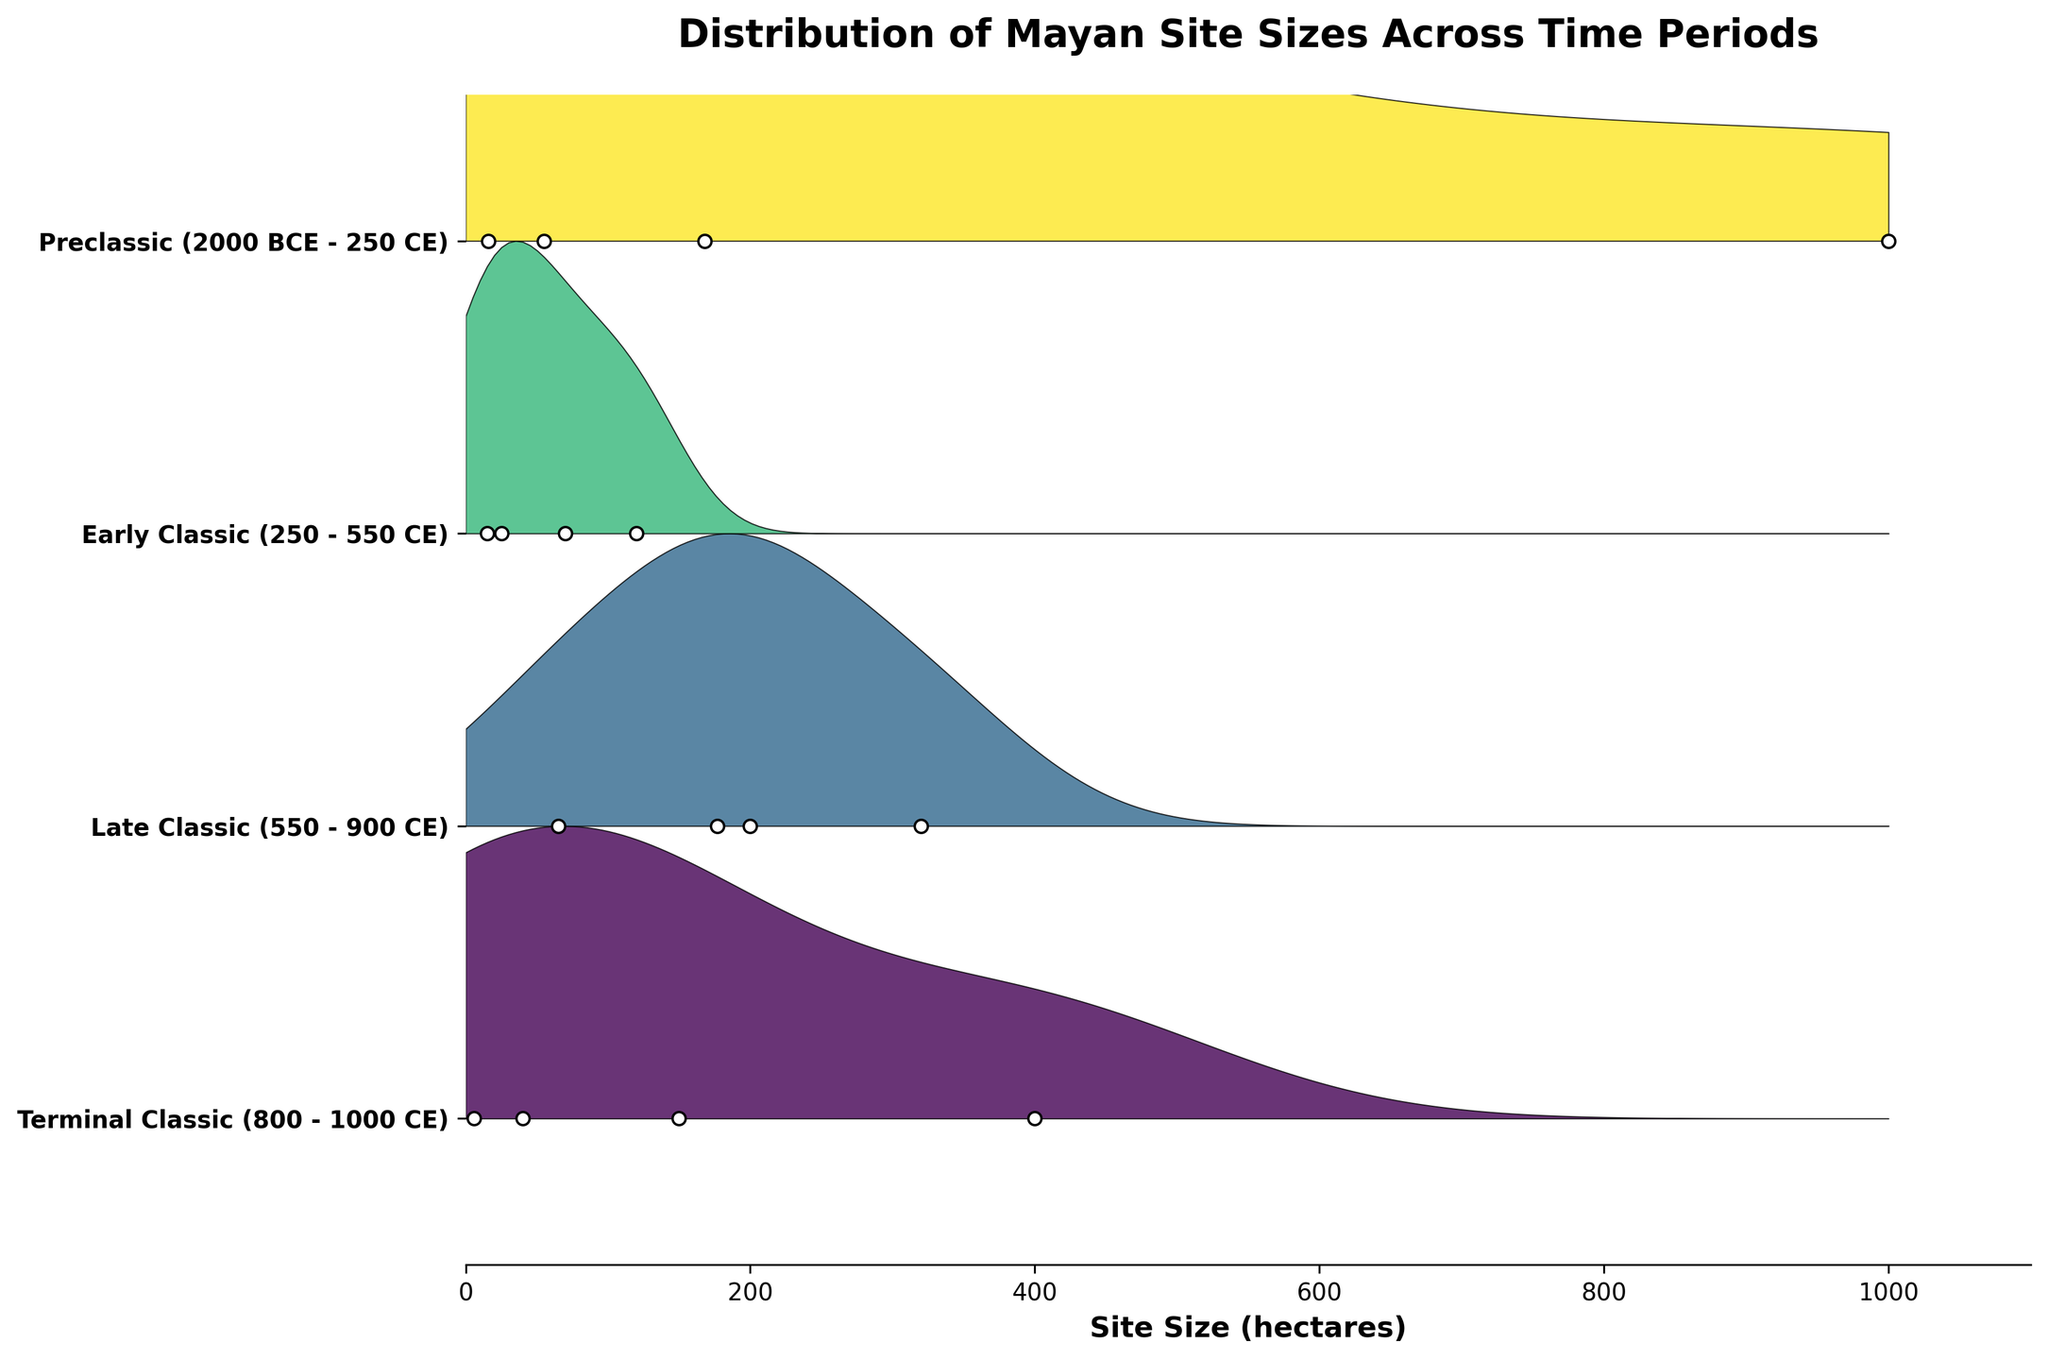What is the title of the plot? The title of the plot is typically displayed at the top in a larger font. In this figure, look at the central position on top.
Answer: Distribution of Mayan Site Sizes Across Time Periods Which time period has the largest maximum site size? Look for the period with the rightmost extent of the filled area in the ridgeline plot. This indicates the maximum site size.
Answer: Preclassic (2000 BCE - 250 CE) How many time periods are compared in the plot? Count the number of distinct ridges in the plot, each representing a different time period.
Answer: Four Which site has the smallest size during the Terminal Classic period? Look at the scatter points for the Terminal Classic period and identify the one with the lowest value on the x-axis.
Answer: Tulum How does the distribution of site sizes change from the Early Classic to the Late Classic period? Compare the width and spread of the ridgeline in the Early Classic to that in the Late Classic period to understand the change in distribution. The distribution would show how site sizes generally change.
Answer: It widens, indicating an increase in site sizes Which time periods show the greatest variation in site sizes? Examine the width of the filled areas for each period. The greater the horizontal spread, the larger the variation in site sizes.
Answer: Preclassic and Late Classic What is the approximate size of Tikal during the Late Classic period? Look for the scatter point labeled "Tikal" within the Late Classic section and read its x-axis value.
Answer: 320 hectares Compare the average site sizes between the Preclassic and Terminal Classic periods. Visually estimate the "center" of the ridges for both periods where most data points lie and compare these central tendencies. A more detailed analysis requires calculation with actual data values.
Answer: The average size is larger in the Terminal Classic period In which period do the sites appear to be more uniformly distributed in size? Look for the period with a relatively narrower and more consistent height in the ridgeline, indicating less variability in sizes.
Answer: Early Classic (250 - 550 CE) Which period shows the earliest development of large urban centers? Identify the earliest time period on the y-axis and check for significant site sizes within that period.
Answer: Preclassic (2000 BCE - 250 CE) 